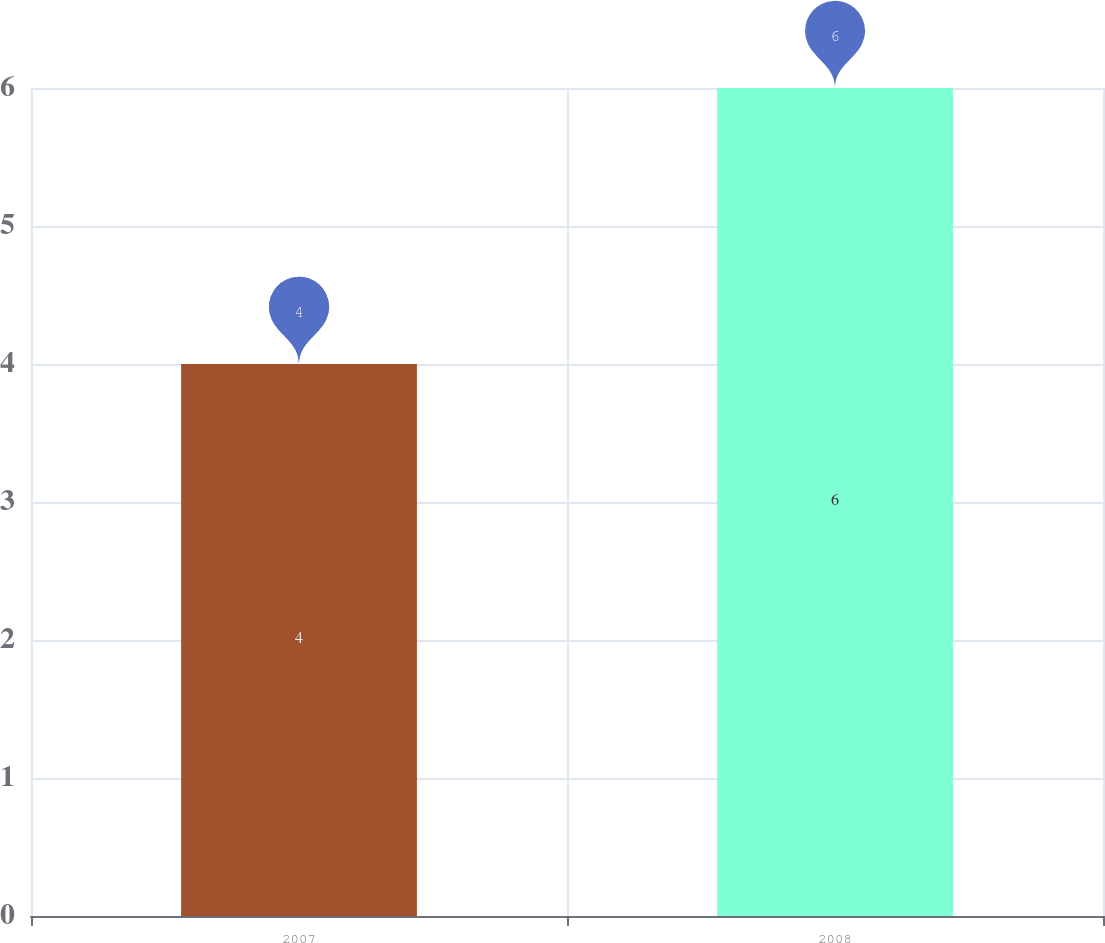Convert chart to OTSL. <chart><loc_0><loc_0><loc_500><loc_500><bar_chart><fcel>2007<fcel>2008<nl><fcel>4<fcel>6<nl></chart> 